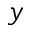<formula> <loc_0><loc_0><loc_500><loc_500>y</formula> 